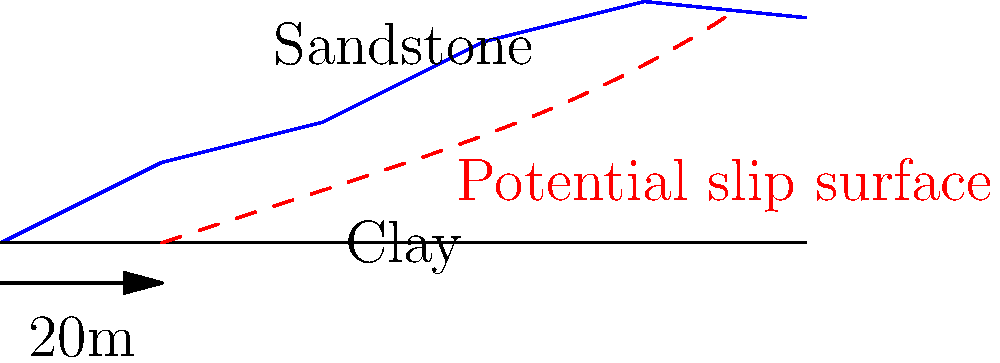Based on the cross-sectional diagram of a hillside, what is the primary factor contributing to the potential slope instability, and what method would you recommend to improve the slope's stability? To analyze the slope stability and recommend an improvement method, we need to consider several factors:

1. Slope geometry: The diagram shows a relatively steep slope, especially in the upper portion.

2. Geological layers: We can observe two main layers - clay at the bottom and sandstone at the top.

3. Potential slip surface: A curved slip surface is indicated, which is typical in rotational slope failures.

4. Layer properties:
   a) Clay: Generally has lower shear strength, especially when saturated.
   b) Sandstone: Usually has higher strength but can be weakened by weathering or joints.

5. Primary factor contributing to instability:
   The presence of a clay layer at the base of the slope is likely the primary factor. Clay can lose strength when saturated, leading to a reduction in the slope's factor of safety.

6. Recommended method to improve stability:
   Given the geological conditions and the potential slip surface, a suitable method would be to install soil nails or rock bolts. This method would:
   a) Increase the shear strength along the potential failure surface.
   b) Provide additional resistance against rotational movement.
   c) Be effective in both the clay and sandstone layers.

7. Implementation:
   Soil nails or rock bolts would be installed perpendicular to the slope face, extending beyond the potential slip surface. They would be grouted in place to provide tension resistance and increase the overall shear strength of the slope.

8. Additional considerations:
   a) Proper drainage should be implemented to reduce pore water pressure in the clay layer.
   b) The slope face could be protected with shotcrete or other erosion control measures.
   c) Regular monitoring of the slope should be conducted to assess its performance over time.
Answer: Clay layer at base; recommend soil nailing or rock bolting. 